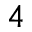<formula> <loc_0><loc_0><loc_500><loc_500>^ { 4 }</formula> 